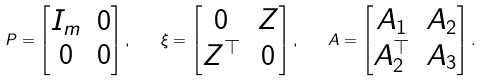Convert formula to latex. <formula><loc_0><loc_0><loc_500><loc_500>P = \begin{bmatrix} I _ { m } & 0 \\ 0 & 0 \end{bmatrix} , \quad \xi = \begin{bmatrix} 0 & Z \\ Z ^ { \top } & 0 \end{bmatrix} , \quad A = \begin{bmatrix} A _ { 1 } & A _ { 2 } \\ A _ { 2 } ^ { \top } & A _ { 3 } \end{bmatrix} .</formula> 